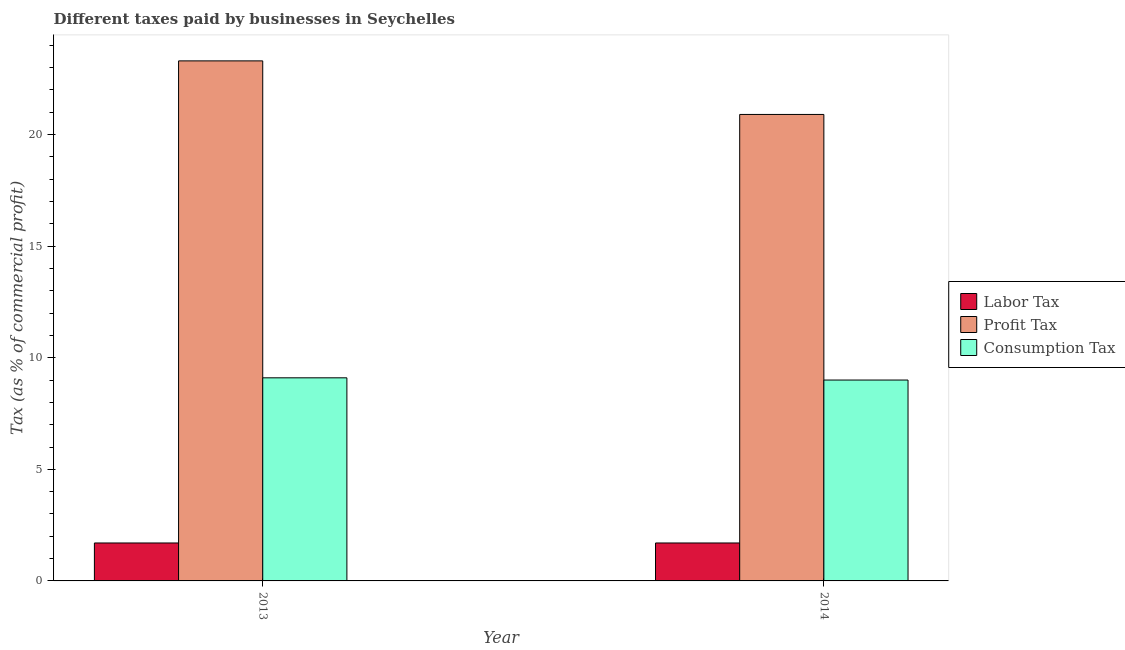How many different coloured bars are there?
Give a very brief answer. 3. How many groups of bars are there?
Provide a succinct answer. 2. Are the number of bars per tick equal to the number of legend labels?
Offer a terse response. Yes. How many bars are there on the 1st tick from the left?
Your answer should be very brief. 3. In how many cases, is the number of bars for a given year not equal to the number of legend labels?
Give a very brief answer. 0. What is the percentage of consumption tax in 2014?
Offer a terse response. 9. Across all years, what is the maximum percentage of consumption tax?
Your response must be concise. 9.1. In which year was the percentage of labor tax maximum?
Make the answer very short. 2013. In which year was the percentage of labor tax minimum?
Make the answer very short. 2013. What is the total percentage of profit tax in the graph?
Your response must be concise. 44.2. What is the difference between the percentage of consumption tax in 2014 and the percentage of profit tax in 2013?
Make the answer very short. -0.1. What is the average percentage of labor tax per year?
Make the answer very short. 1.7. What is the ratio of the percentage of consumption tax in 2013 to that in 2014?
Keep it short and to the point. 1.01. Is the percentage of profit tax in 2013 less than that in 2014?
Ensure brevity in your answer.  No. In how many years, is the percentage of consumption tax greater than the average percentage of consumption tax taken over all years?
Keep it short and to the point. 1. What does the 2nd bar from the left in 2014 represents?
Your answer should be compact. Profit Tax. What does the 1st bar from the right in 2013 represents?
Make the answer very short. Consumption Tax. What is the difference between two consecutive major ticks on the Y-axis?
Offer a terse response. 5. Are the values on the major ticks of Y-axis written in scientific E-notation?
Your response must be concise. No. Where does the legend appear in the graph?
Provide a succinct answer. Center right. What is the title of the graph?
Your answer should be very brief. Different taxes paid by businesses in Seychelles. Does "Textiles and clothing" appear as one of the legend labels in the graph?
Offer a very short reply. No. What is the label or title of the X-axis?
Make the answer very short. Year. What is the label or title of the Y-axis?
Offer a terse response. Tax (as % of commercial profit). What is the Tax (as % of commercial profit) in Profit Tax in 2013?
Offer a very short reply. 23.3. What is the Tax (as % of commercial profit) of Labor Tax in 2014?
Provide a succinct answer. 1.7. What is the Tax (as % of commercial profit) of Profit Tax in 2014?
Give a very brief answer. 20.9. What is the Tax (as % of commercial profit) of Consumption Tax in 2014?
Offer a terse response. 9. Across all years, what is the maximum Tax (as % of commercial profit) of Labor Tax?
Provide a succinct answer. 1.7. Across all years, what is the maximum Tax (as % of commercial profit) of Profit Tax?
Offer a terse response. 23.3. Across all years, what is the minimum Tax (as % of commercial profit) in Labor Tax?
Your answer should be compact. 1.7. Across all years, what is the minimum Tax (as % of commercial profit) of Profit Tax?
Give a very brief answer. 20.9. Across all years, what is the minimum Tax (as % of commercial profit) in Consumption Tax?
Keep it short and to the point. 9. What is the total Tax (as % of commercial profit) of Labor Tax in the graph?
Give a very brief answer. 3.4. What is the total Tax (as % of commercial profit) in Profit Tax in the graph?
Your answer should be very brief. 44.2. What is the total Tax (as % of commercial profit) in Consumption Tax in the graph?
Offer a very short reply. 18.1. What is the difference between the Tax (as % of commercial profit) in Labor Tax in 2013 and that in 2014?
Give a very brief answer. 0. What is the difference between the Tax (as % of commercial profit) of Consumption Tax in 2013 and that in 2014?
Your answer should be very brief. 0.1. What is the difference between the Tax (as % of commercial profit) in Labor Tax in 2013 and the Tax (as % of commercial profit) in Profit Tax in 2014?
Provide a succinct answer. -19.2. What is the difference between the Tax (as % of commercial profit) in Profit Tax in 2013 and the Tax (as % of commercial profit) in Consumption Tax in 2014?
Ensure brevity in your answer.  14.3. What is the average Tax (as % of commercial profit) in Labor Tax per year?
Your answer should be compact. 1.7. What is the average Tax (as % of commercial profit) in Profit Tax per year?
Give a very brief answer. 22.1. What is the average Tax (as % of commercial profit) of Consumption Tax per year?
Ensure brevity in your answer.  9.05. In the year 2013, what is the difference between the Tax (as % of commercial profit) of Labor Tax and Tax (as % of commercial profit) of Profit Tax?
Keep it short and to the point. -21.6. In the year 2013, what is the difference between the Tax (as % of commercial profit) in Profit Tax and Tax (as % of commercial profit) in Consumption Tax?
Your response must be concise. 14.2. In the year 2014, what is the difference between the Tax (as % of commercial profit) of Labor Tax and Tax (as % of commercial profit) of Profit Tax?
Provide a succinct answer. -19.2. In the year 2014, what is the difference between the Tax (as % of commercial profit) in Profit Tax and Tax (as % of commercial profit) in Consumption Tax?
Provide a short and direct response. 11.9. What is the ratio of the Tax (as % of commercial profit) of Profit Tax in 2013 to that in 2014?
Provide a succinct answer. 1.11. What is the ratio of the Tax (as % of commercial profit) of Consumption Tax in 2013 to that in 2014?
Offer a terse response. 1.01. What is the difference between the highest and the second highest Tax (as % of commercial profit) in Labor Tax?
Provide a succinct answer. 0. What is the difference between the highest and the lowest Tax (as % of commercial profit) of Labor Tax?
Give a very brief answer. 0. 